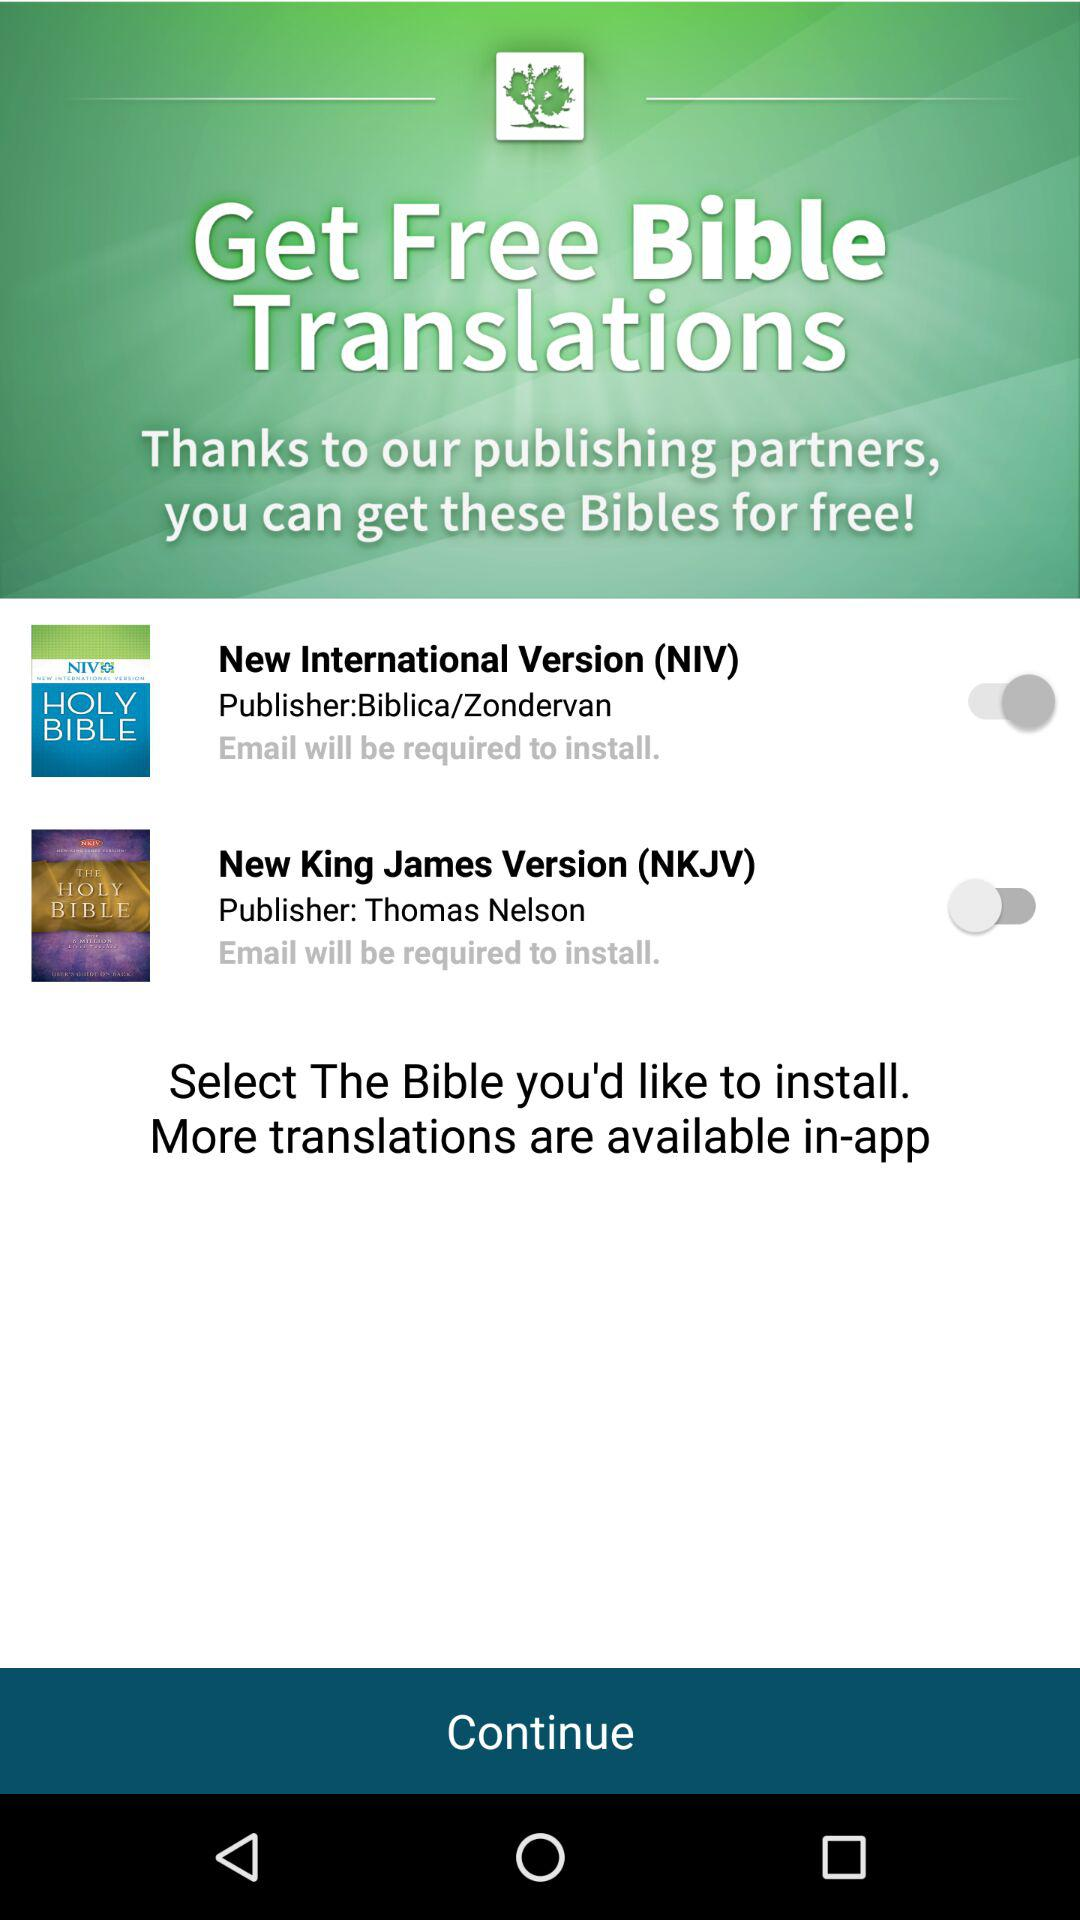Who is the publisher of the "New King James Version"? The publisher of the "New King James Version" is Thomas Nelson. 